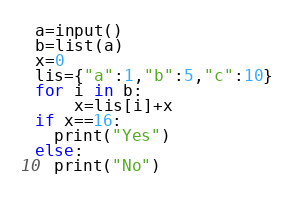<code> <loc_0><loc_0><loc_500><loc_500><_Python_>a=input()
b=list(a)
x=0
lis={"a":1,"b":5,"c":10}
for i in b:
    x=lis[i]+x
if x==16:
  print("Yes")
else:
  print("No")

  </code> 